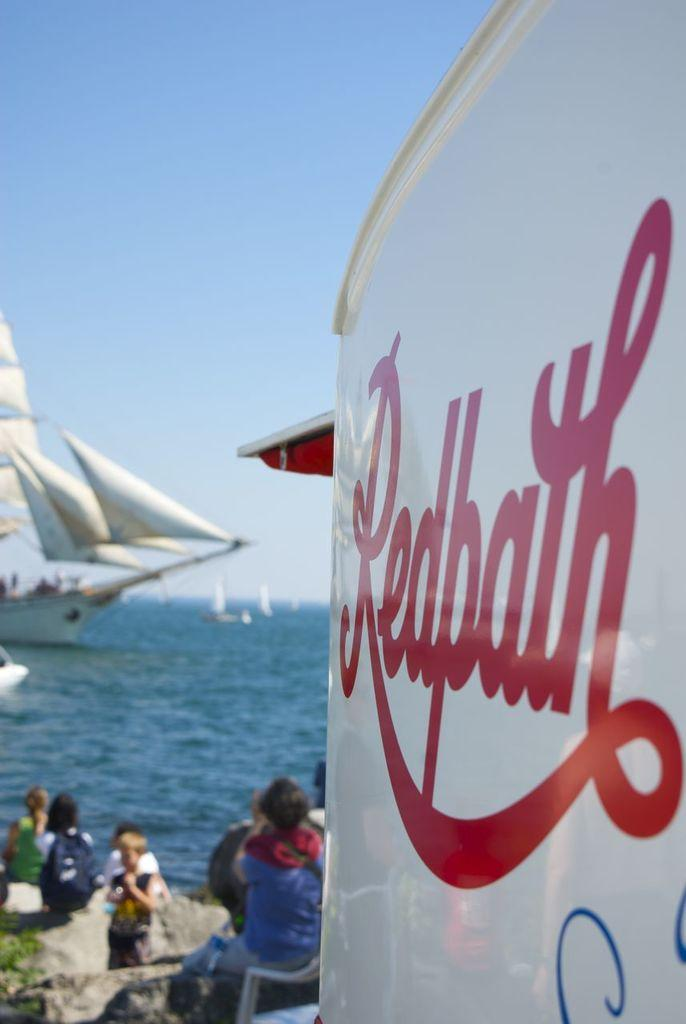<image>
Present a compact description of the photo's key features. A white sign, reading Redpath, is in front of some people. 